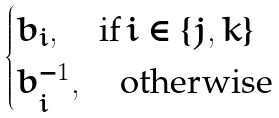Convert formula to latex. <formula><loc_0><loc_0><loc_500><loc_500>\begin{cases} b _ { i } , \quad \text {if} \, i \in \{ j , k \} \\ b _ { i } ^ { - 1 } , \quad \text {otherwise} \end{cases}</formula> 